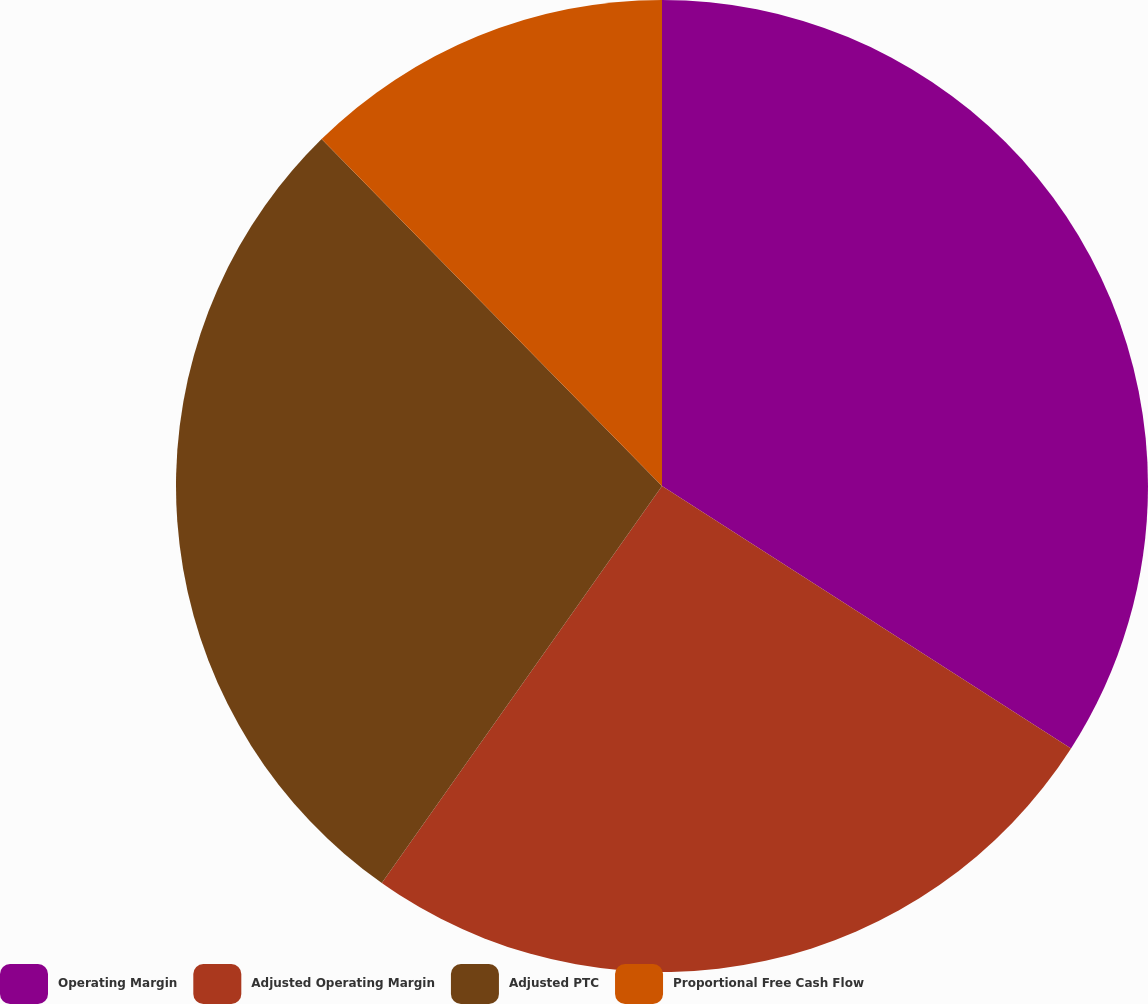<chart> <loc_0><loc_0><loc_500><loc_500><pie_chart><fcel>Operating Margin<fcel>Adjusted Operating Margin<fcel>Adjusted PTC<fcel>Proportional Free Cash Flow<nl><fcel>34.08%<fcel>25.7%<fcel>27.87%<fcel>12.35%<nl></chart> 